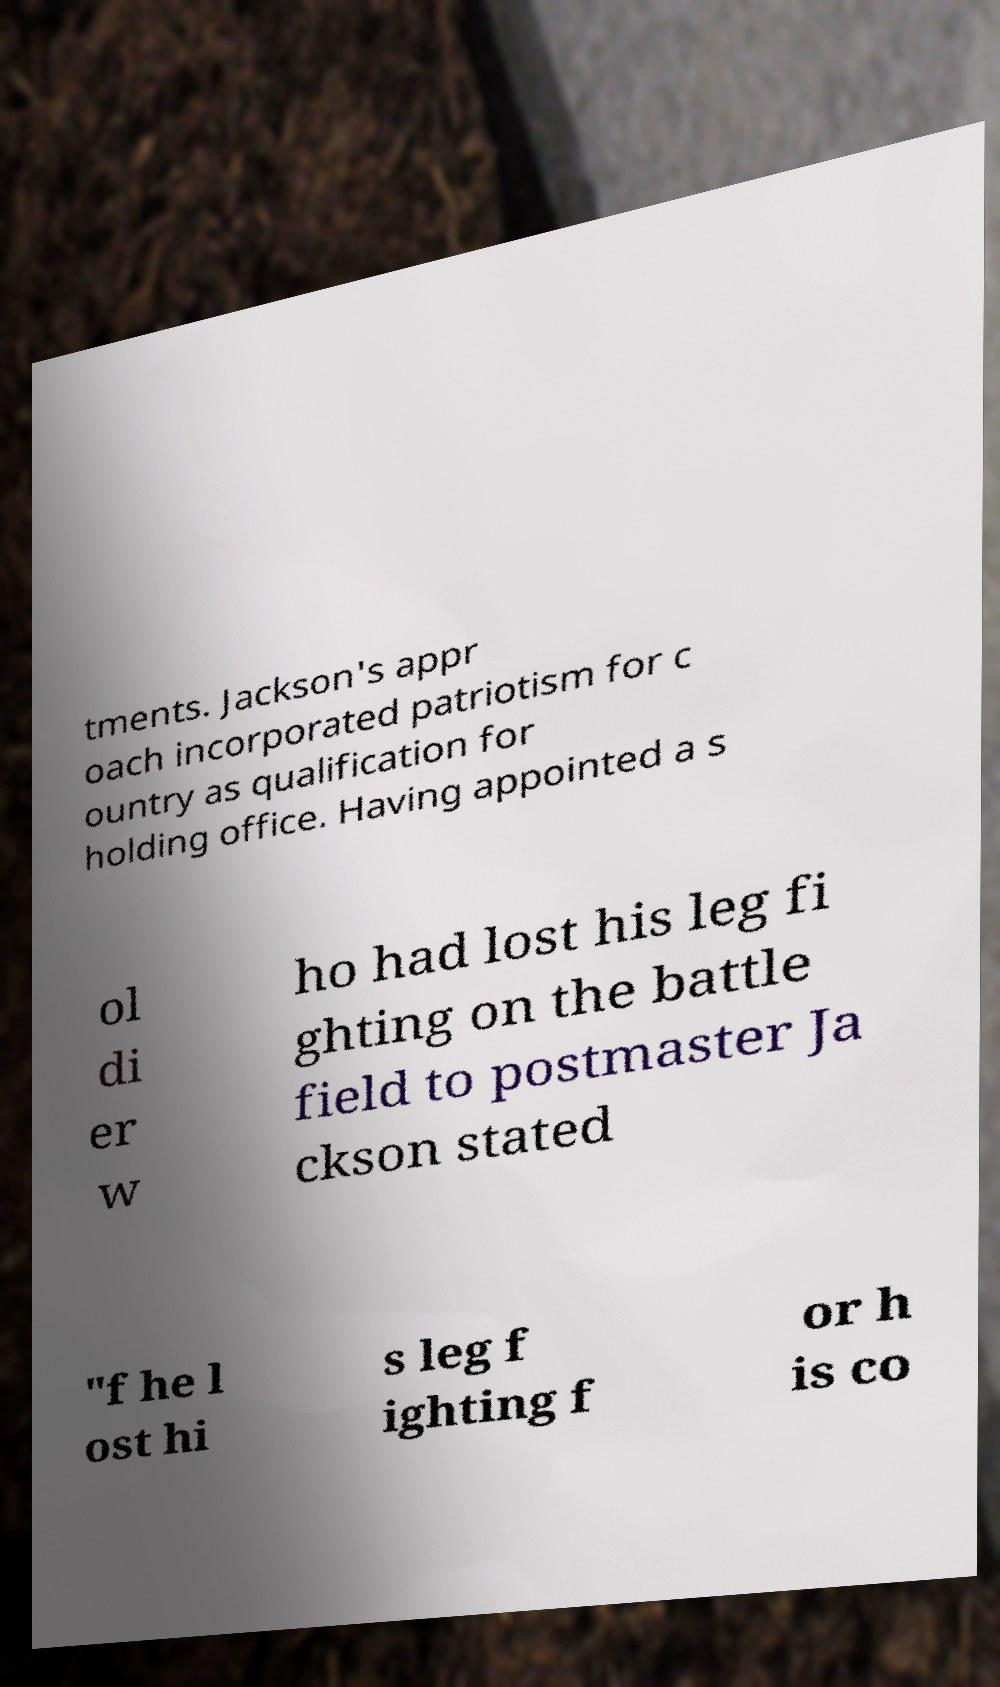What messages or text are displayed in this image? I need them in a readable, typed format. tments. Jackson's appr oach incorporated patriotism for c ountry as qualification for holding office. Having appointed a s ol di er w ho had lost his leg fi ghting on the battle field to postmaster Ja ckson stated "f he l ost hi s leg f ighting f or h is co 